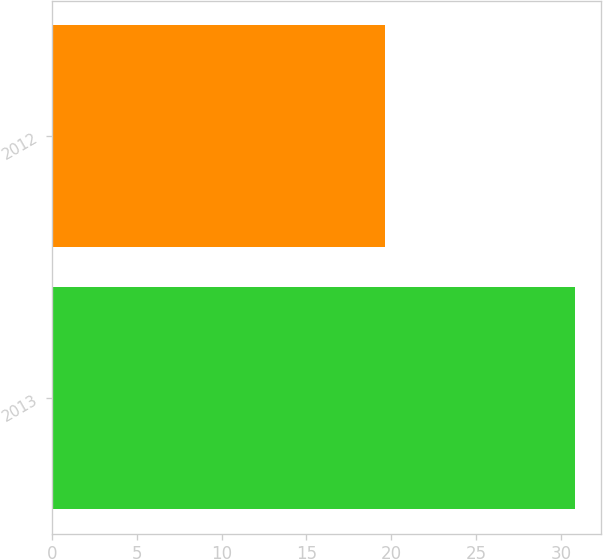Convert chart. <chart><loc_0><loc_0><loc_500><loc_500><bar_chart><fcel>2013<fcel>2012<nl><fcel>30.85<fcel>19.65<nl></chart> 